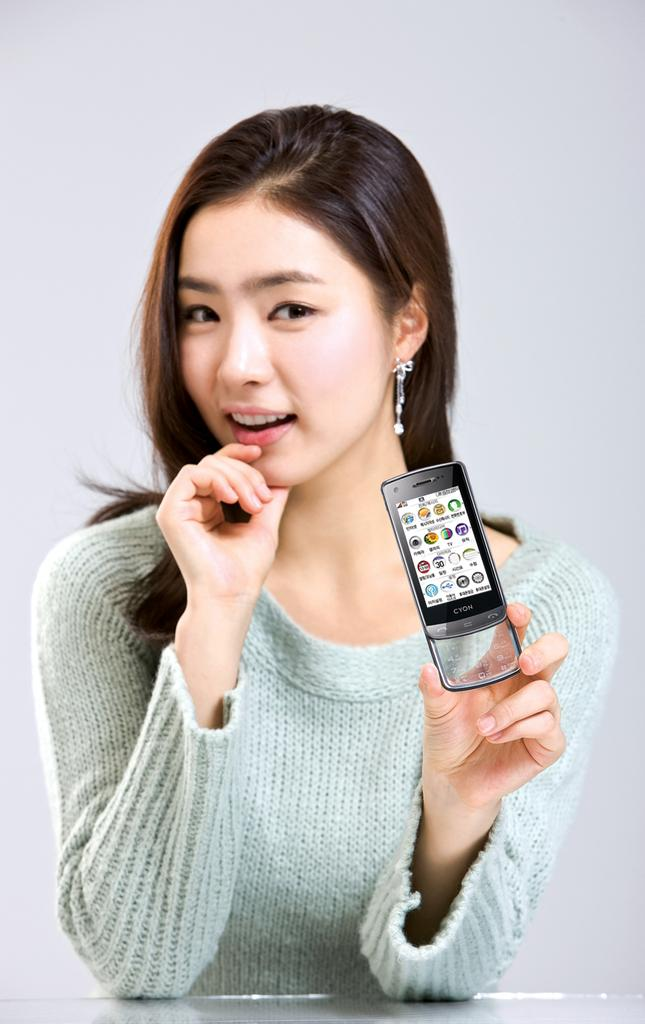What can be seen in the image? There is a person in the image. What is the person holding? The person is holding a mobile phone. How would you describe the person's clothing? The person is wearing colorful clothes. What type of button can be seen on the person's vein in the image? There is no button or vein visible on the person in the image. 